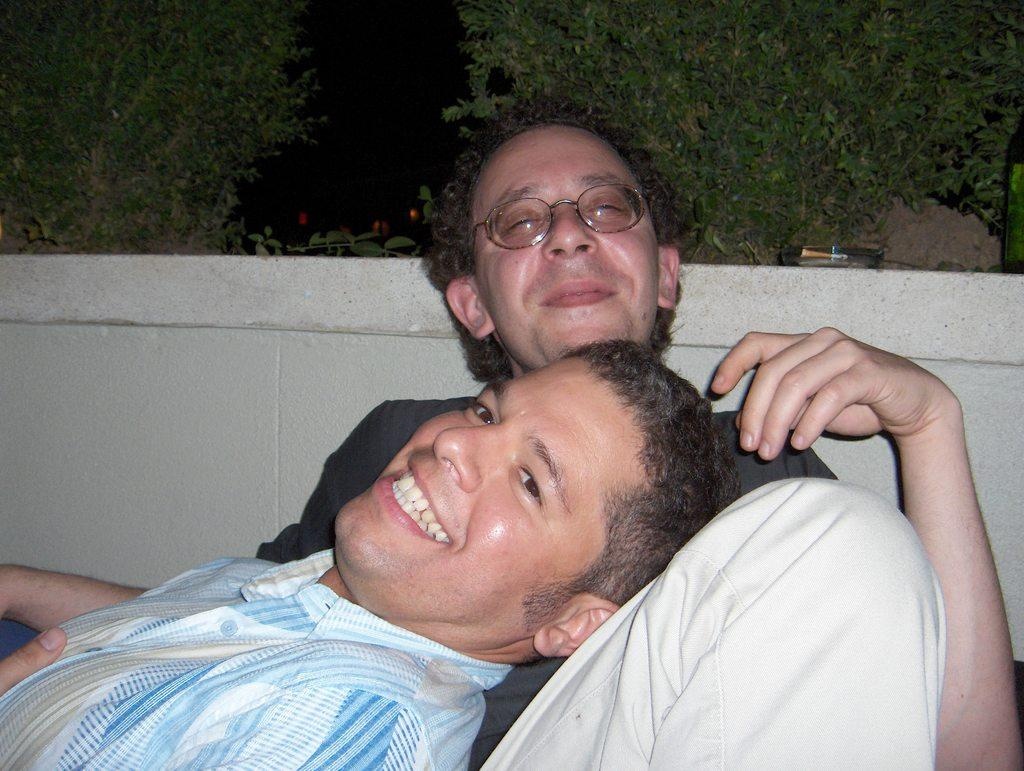How many people are in the image? There are two men in the image. What is the facial expression of the men in the image? Both men are smiling. Can you describe any specific feature of one of the men? One of the men is wearing spectacles. What can be seen in the background of the image? There is a wall and trees in the background of the image. What type of toothbrush can be seen in the image? There is no toothbrush present in the image. What ornament is hanging from the wall in the image? There is no ornament hanging from the wall in the image. 